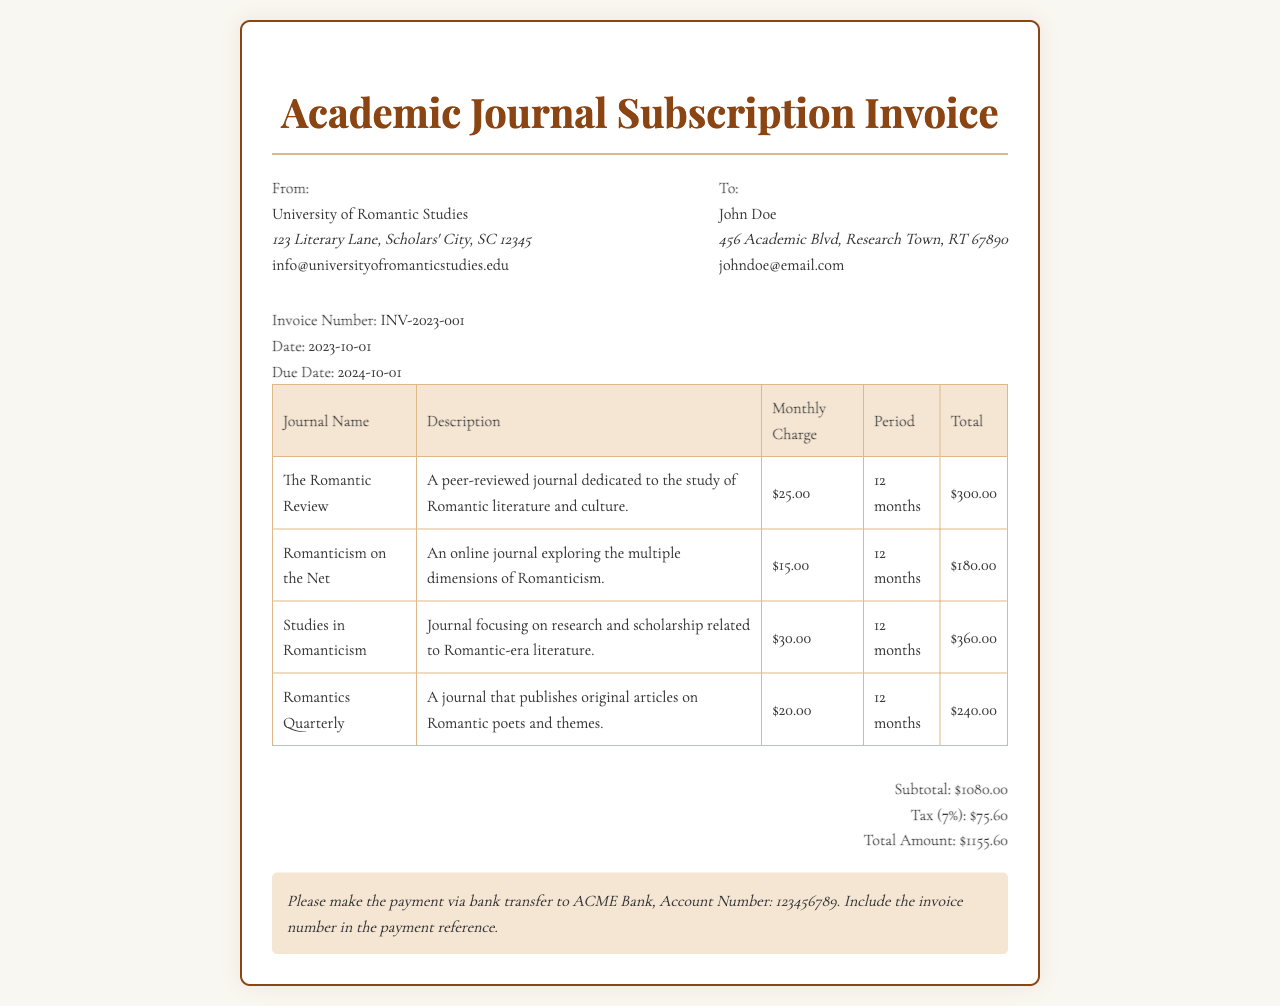What is the invoice number? The invoice number is a unique identifier for this transaction and can be found in the header section of the invoice.
Answer: INV-2023-001 Who is the recipient of the invoice? The recipient's name is provided in the "To" section of the invoice.
Answer: John Doe What is the total amount due? The total amount is the final figure calculated, which includes the subtotal and tax.
Answer: $1155.60 What is the due date for payment? The due date is specified, indicating when the payment should be made.
Answer: 2024-10-01 How many types of journals are listed in the invoice? The number of journal entries indicates the diversity of subscriptions covered in the invoice.
Answer: 4 What is the monthly charge for "The Romantic Review"? The charge for this journal can be found in the table listing the subscription details.
Answer: $25.00 What is the tax percentage applied to the invoice? The tax percentage is stated in the invoice and contributes to the total amount due.
Answer: 7% What is the subtotal amount before tax? The subtotal is the total cost of the subscriptions before tax is calculated.
Answer: $1080.00 What payment method is specified in the instructions? The invoice provides clear instructions on how the payment should be made.
Answer: Bank transfer 